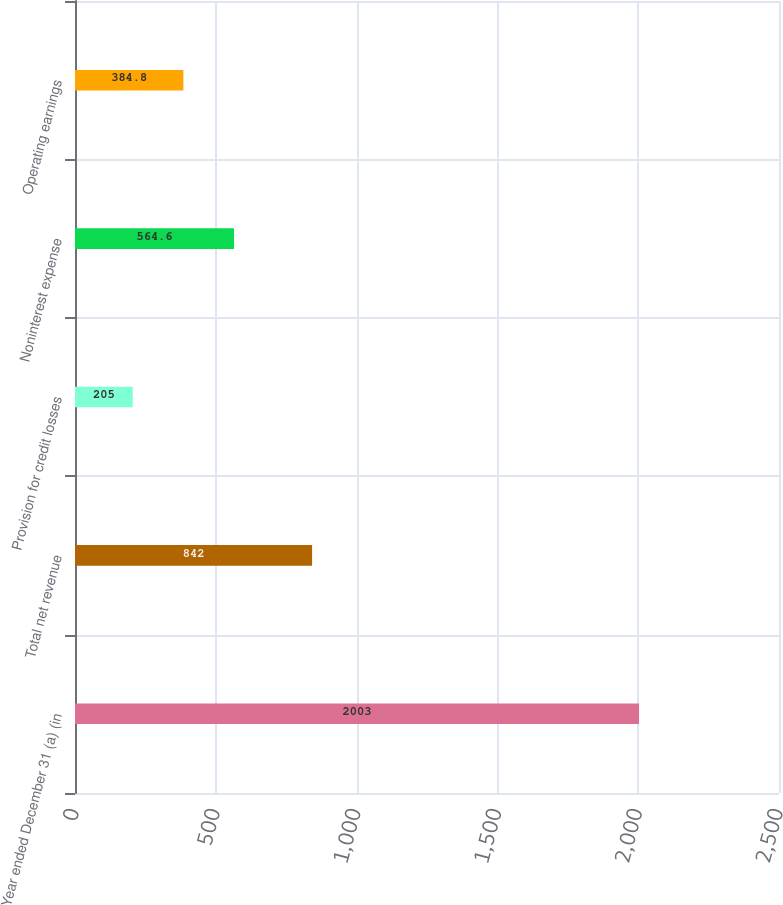Convert chart. <chart><loc_0><loc_0><loc_500><loc_500><bar_chart><fcel>Year ended December 31 (a) (in<fcel>Total net revenue<fcel>Provision for credit losses<fcel>Noninterest expense<fcel>Operating earnings<nl><fcel>2003<fcel>842<fcel>205<fcel>564.6<fcel>384.8<nl></chart> 